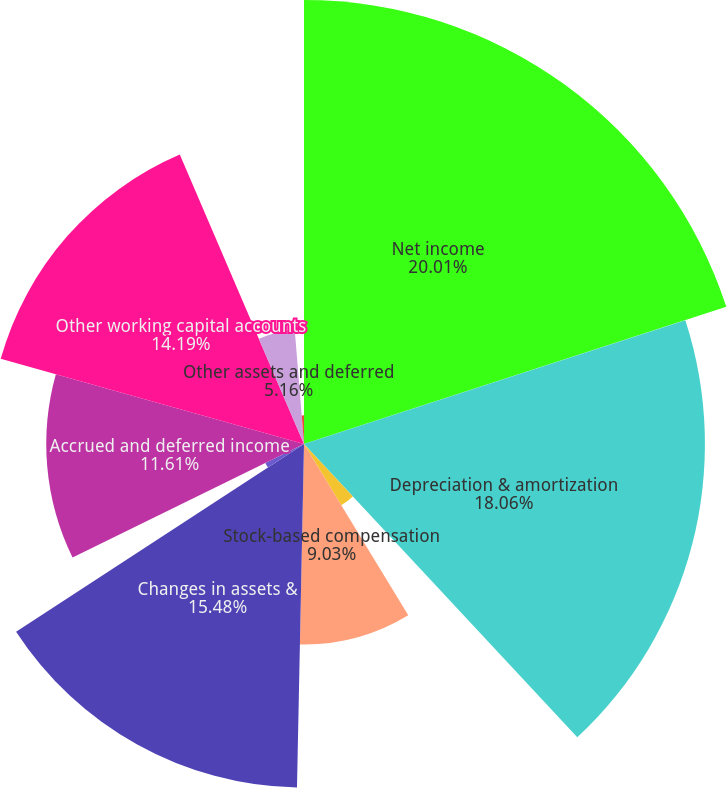<chart> <loc_0><loc_0><loc_500><loc_500><pie_chart><fcel>Net income<fcel>Depreciation & amortization<fcel>Gains on sales of assets and<fcel>Stock-based compensation<fcel>Changes in assets &<fcel>Accrued interest<fcel>Accrued and deferred income<fcel>Other working capital accounts<fcel>Other assets and deferred<fcel>Other<nl><fcel>20.0%<fcel>18.06%<fcel>3.23%<fcel>9.03%<fcel>15.48%<fcel>1.94%<fcel>11.61%<fcel>14.19%<fcel>5.16%<fcel>1.29%<nl></chart> 